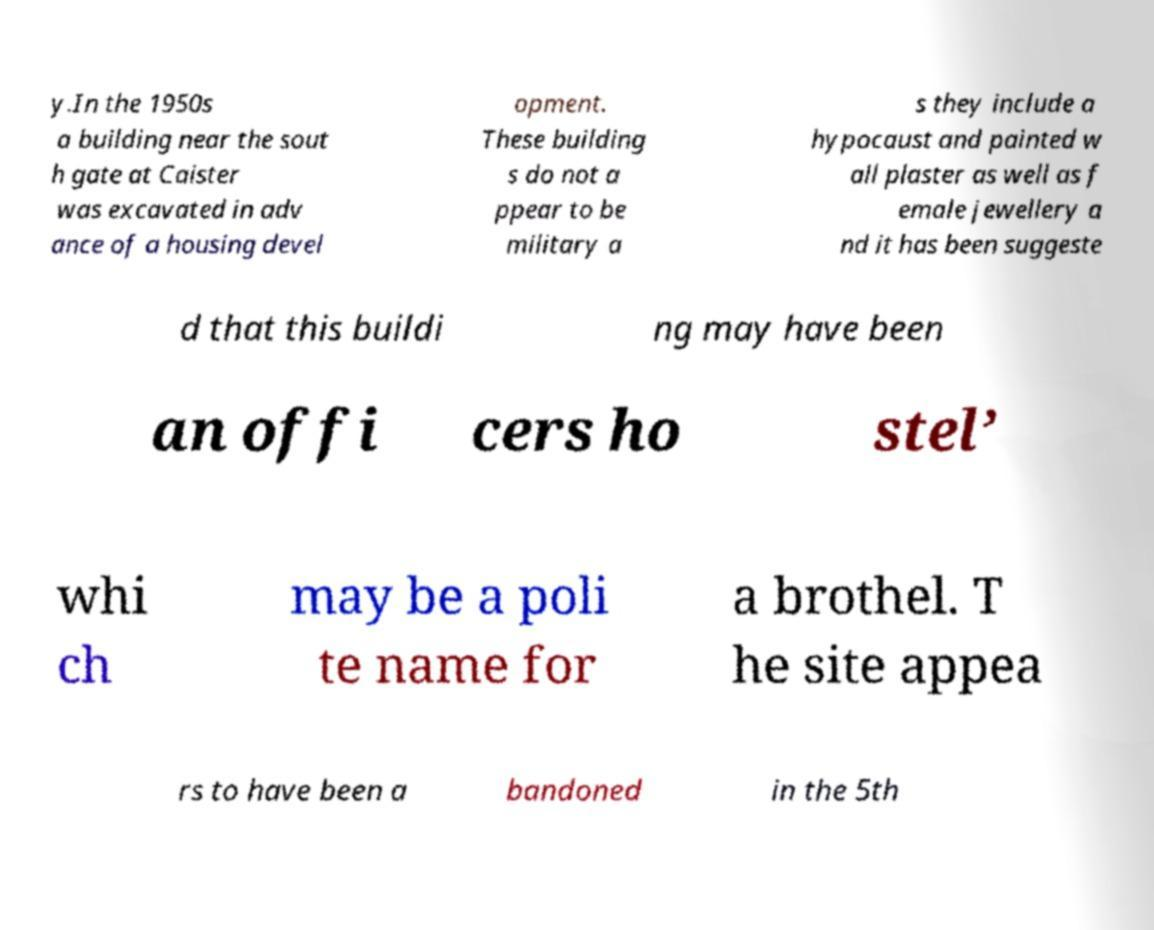I need the written content from this picture converted into text. Can you do that? y.In the 1950s a building near the sout h gate at Caister was excavated in adv ance of a housing devel opment. These building s do not a ppear to be military a s they include a hypocaust and painted w all plaster as well as f emale jewellery a nd it has been suggeste d that this buildi ng may have been an offi cers ho stel’ whi ch may be a poli te name for a brothel. T he site appea rs to have been a bandoned in the 5th 